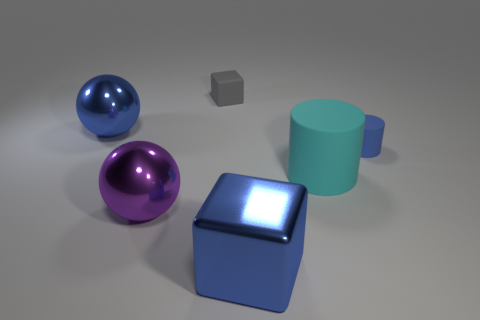Add 3 cyan matte things. How many objects exist? 9 Subtract all cubes. How many objects are left? 4 Subtract all big green metallic balls. Subtract all blue cylinders. How many objects are left? 5 Add 6 purple objects. How many purple objects are left? 7 Add 6 big green shiny things. How many big green shiny things exist? 6 Subtract 0 purple cubes. How many objects are left? 6 